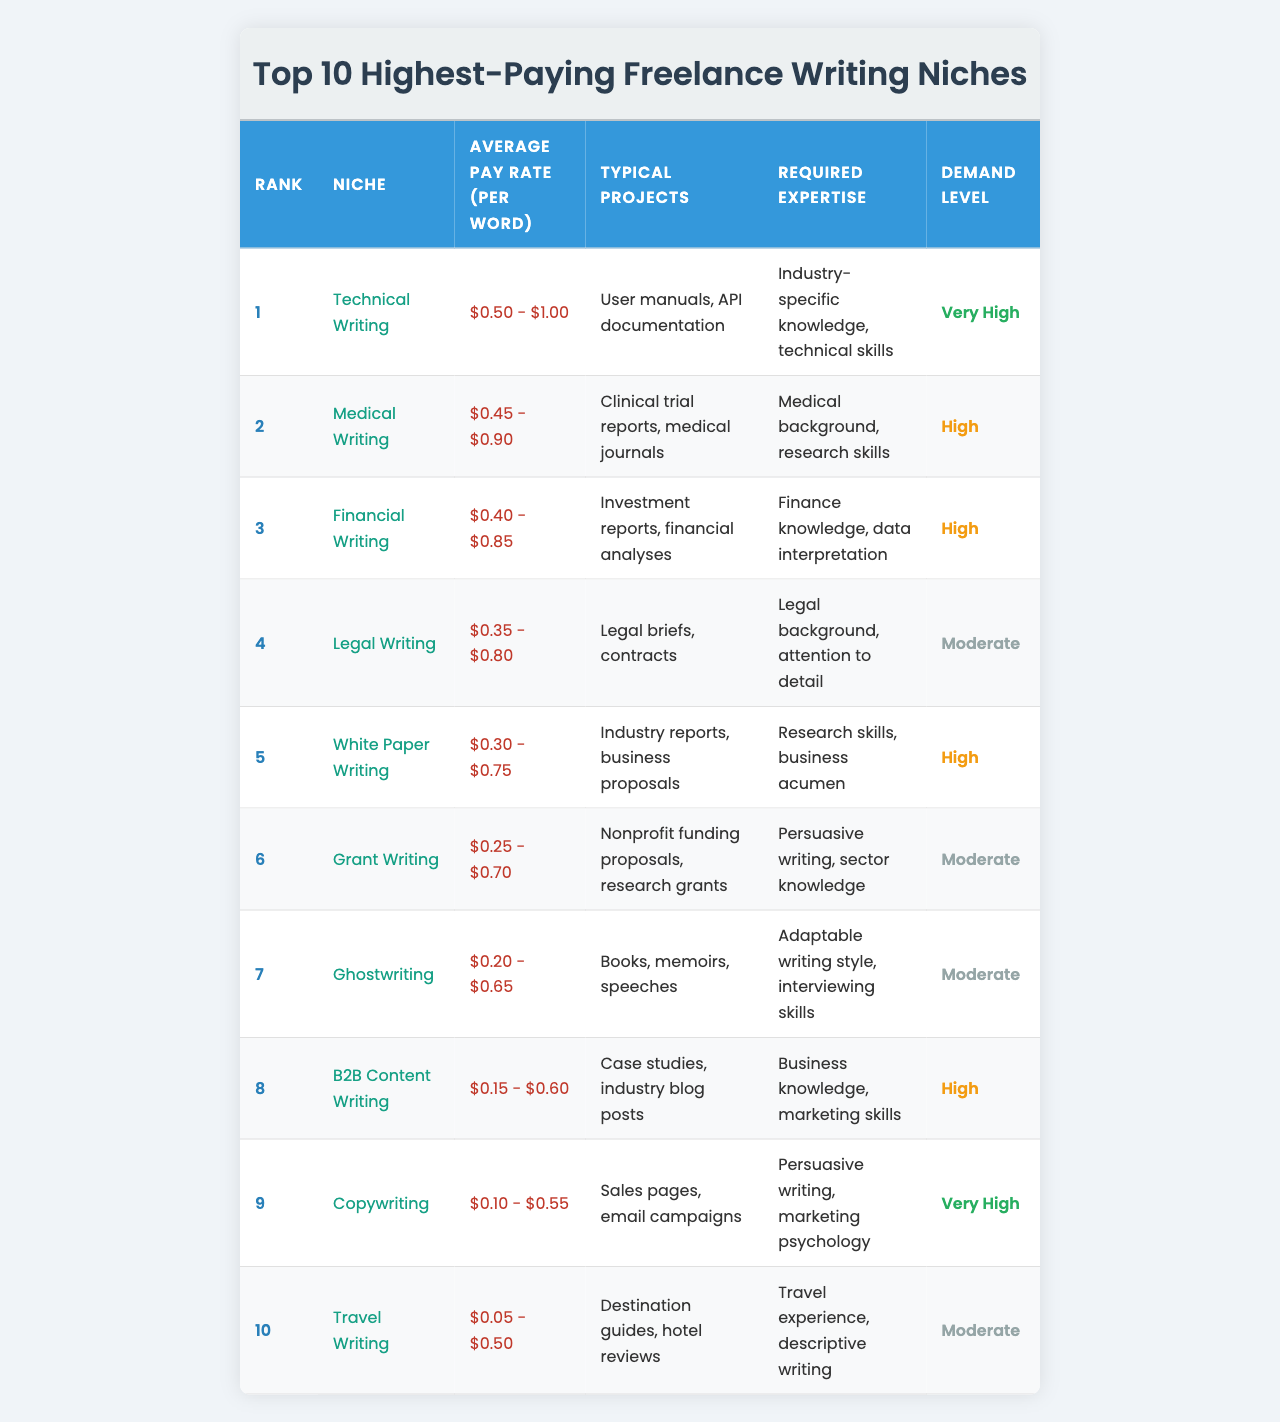What is the highest-paying freelance writing niche? The table lists "Technical Writing" as the highest-paying niche with an average pay rate between $0.50 and $1.00 per word.
Answer: Technical Writing Which niche has an average pay rate between $0.40 and $0.85 per word? The niche that falls within this pay range is "Financial Writing," as shown in the table.
Answer: Financial Writing How many niches have a "Very High" demand level? According to the table, there are two niches: "Technical Writing" and "Copywriting" that are marked with "Very High" demand.
Answer: 2 Does "Grant Writing" have a higher average pay rate than "Ghostwriting"? The average pay rate for "Grant Writing" ranges from $0.25 to $0.70, which is higher than "Ghostwriting," which has an average pay range of $0.20 to $0.65.
Answer: Yes What is the average pay rate for the top three niches combined? The average pay for the top three niches: Technical Writing ($0.75) + Medical Writing ($0.675) + Financial Writing ($0.625) gives us a total of $2.05, and when averaged over 3 niches, it results in approximately $0.683.
Answer: $0.683 What typical projects are associated with "White Paper Writing"? The table indicates that "White Paper Writing" typically involves creating industry reports and business proposals.
Answer: Industry reports, business proposals Which niche requires medical background and research skills? The "Medical Writing" niche specifically requires a medical background and research skills as noted in the table.
Answer: Medical Writing Is "Travel Writing" more in demand than "Legal Writing"? "Travel Writing" is marked as "Moderate" demand, while "Legal Writing" is also listed as "Moderate," so they have the same demand level.
Answer: No What is the lowest average pay rate specified in the table? The lowest average pay rate is associated with "Travel Writing," which ranges from $0.05 to $0.50 per word.
Answer: $0.05 - $0.50 If someone is interested in writing for nonprofits, which niche should they consider? The "Grant Writing" niche specifically involves writing for nonprofit funding proposals, as indicated in the table.
Answer: Grant Writing 